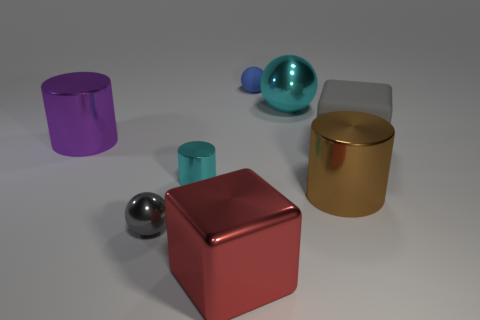How many other objects are there of the same color as the small shiny ball?
Give a very brief answer. 1. What material is the big thing that is both to the right of the gray metallic ball and to the left of the big metal sphere?
Ensure brevity in your answer.  Metal. Do the tiny blue rubber object and the large cyan metal object have the same shape?
Your answer should be compact. Yes. Are there any big red cylinders?
Your answer should be very brief. No. Do the small cyan thing and the big object behind the large purple metallic object have the same shape?
Provide a succinct answer. No. What is the material of the thing on the right side of the cylinder that is to the right of the blue sphere?
Ensure brevity in your answer.  Rubber. The tiny metallic ball has what color?
Provide a short and direct response. Gray. There is a big cube that is behind the large red block; is it the same color as the sphere that is on the left side of the red shiny cube?
Provide a short and direct response. Yes. There is a gray metal object that is the same shape as the small blue rubber thing; what is its size?
Provide a short and direct response. Small. Is there a object of the same color as the shiny block?
Give a very brief answer. No. 